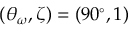Convert formula to latex. <formula><loc_0><loc_0><loc_500><loc_500>( \theta _ { \omega } , \zeta ) = ( 9 0 ^ { \circ } , 1 )</formula> 